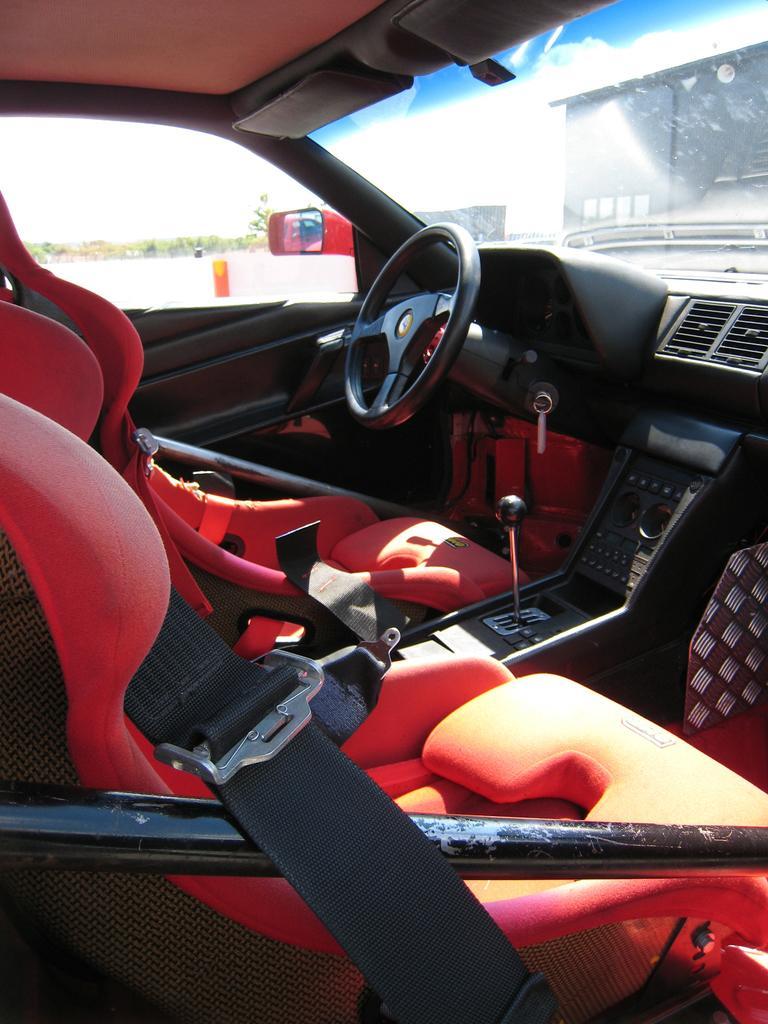How would you summarize this image in a sentence or two? In this picture I can see inner view of a vehicle and I can see a steering and a dashboard and couple of seats and from the vehicle glass I can see trees and buildings. 